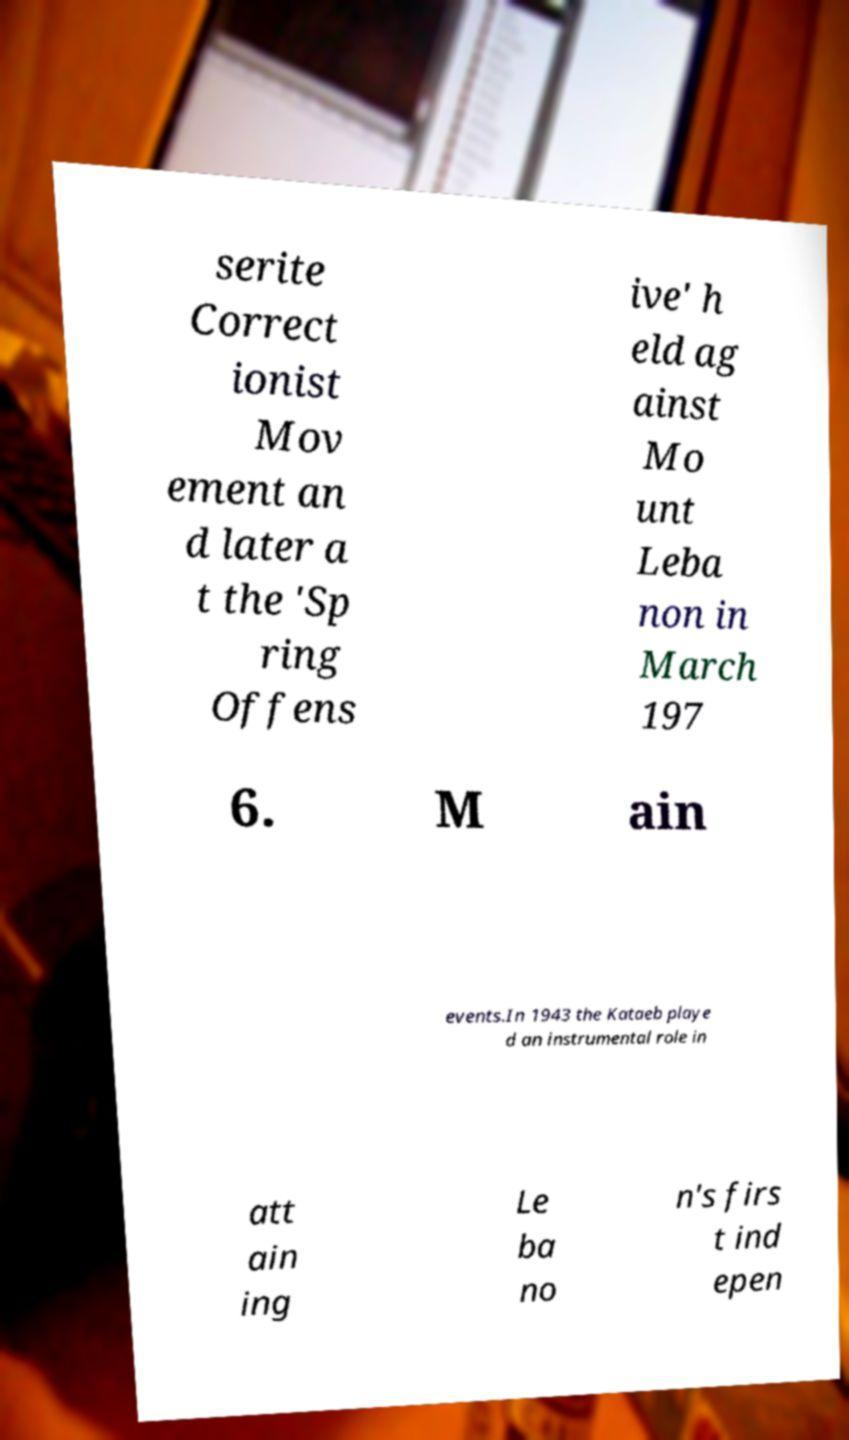Could you assist in decoding the text presented in this image and type it out clearly? serite Correct ionist Mov ement an d later a t the 'Sp ring Offens ive' h eld ag ainst Mo unt Leba non in March 197 6. M ain events.In 1943 the Kataeb playe d an instrumental role in att ain ing Le ba no n's firs t ind epen 